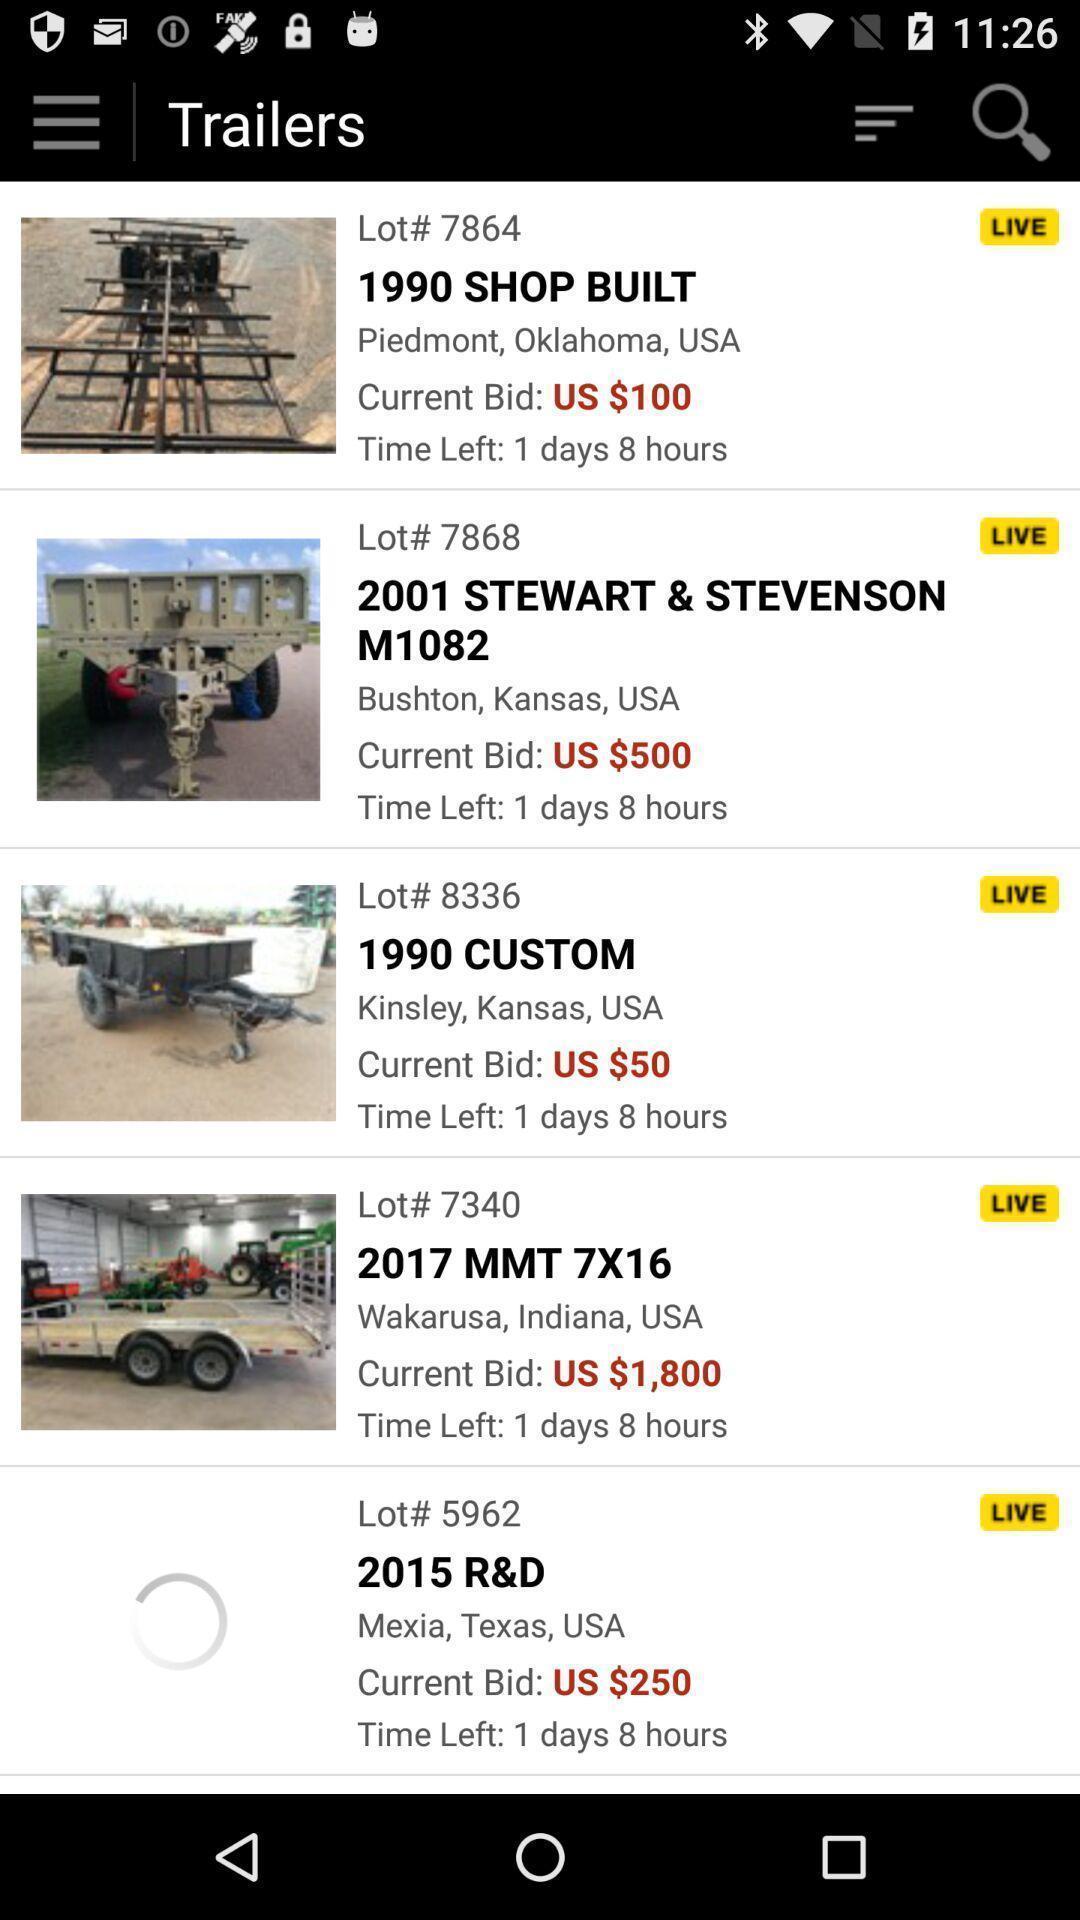Provide a detailed account of this screenshot. Screen displaying multiple pictures with bid prices. 